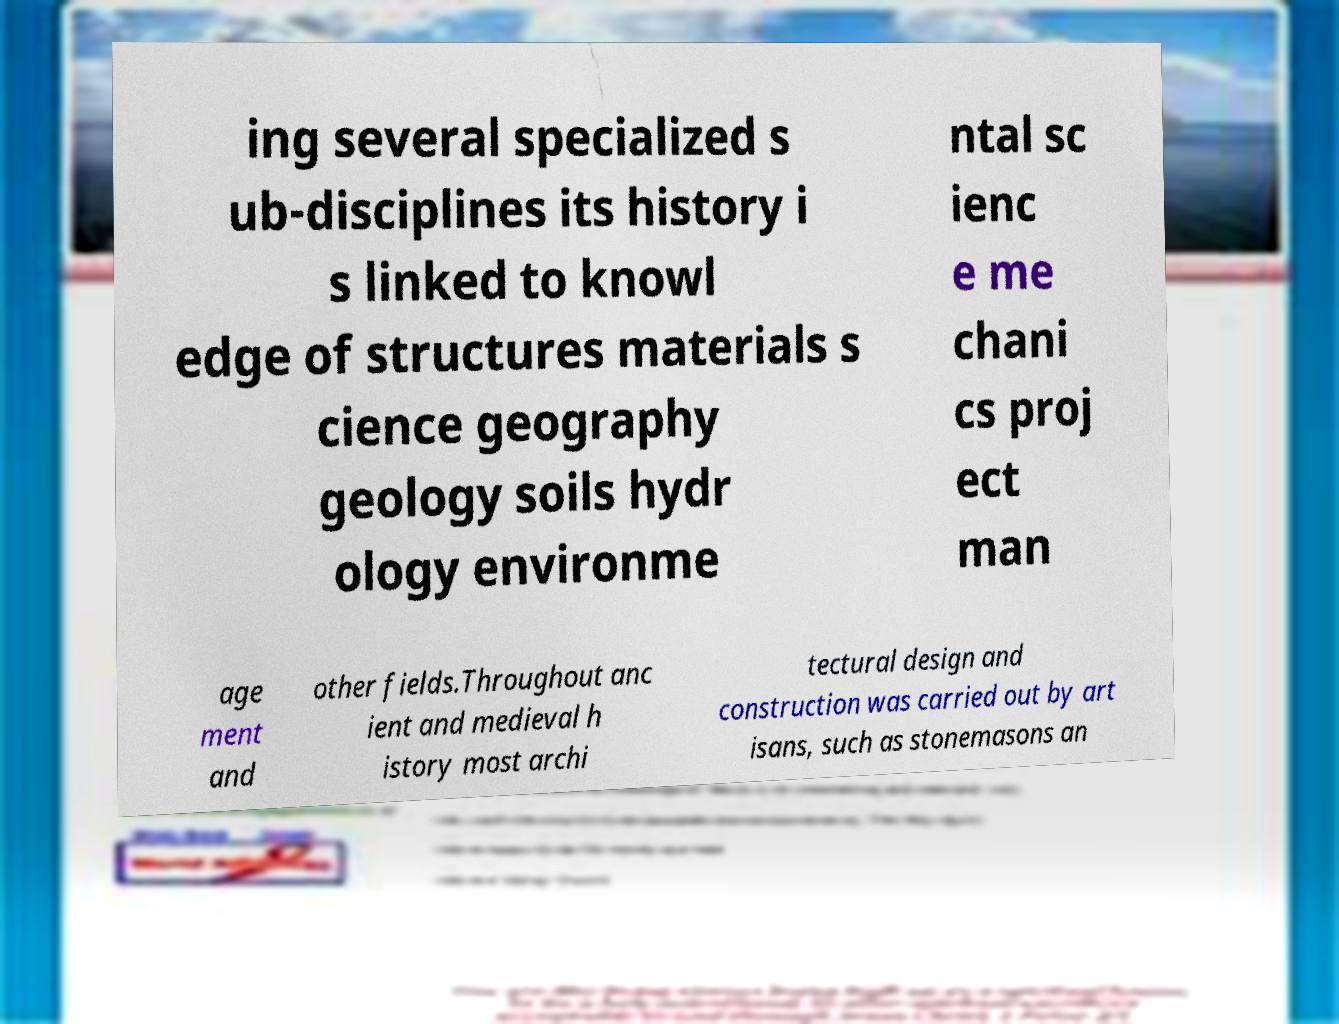What messages or text are displayed in this image? I need them in a readable, typed format. ing several specialized s ub-disciplines its history i s linked to knowl edge of structures materials s cience geography geology soils hydr ology environme ntal sc ienc e me chani cs proj ect man age ment and other fields.Throughout anc ient and medieval h istory most archi tectural design and construction was carried out by art isans, such as stonemasons an 